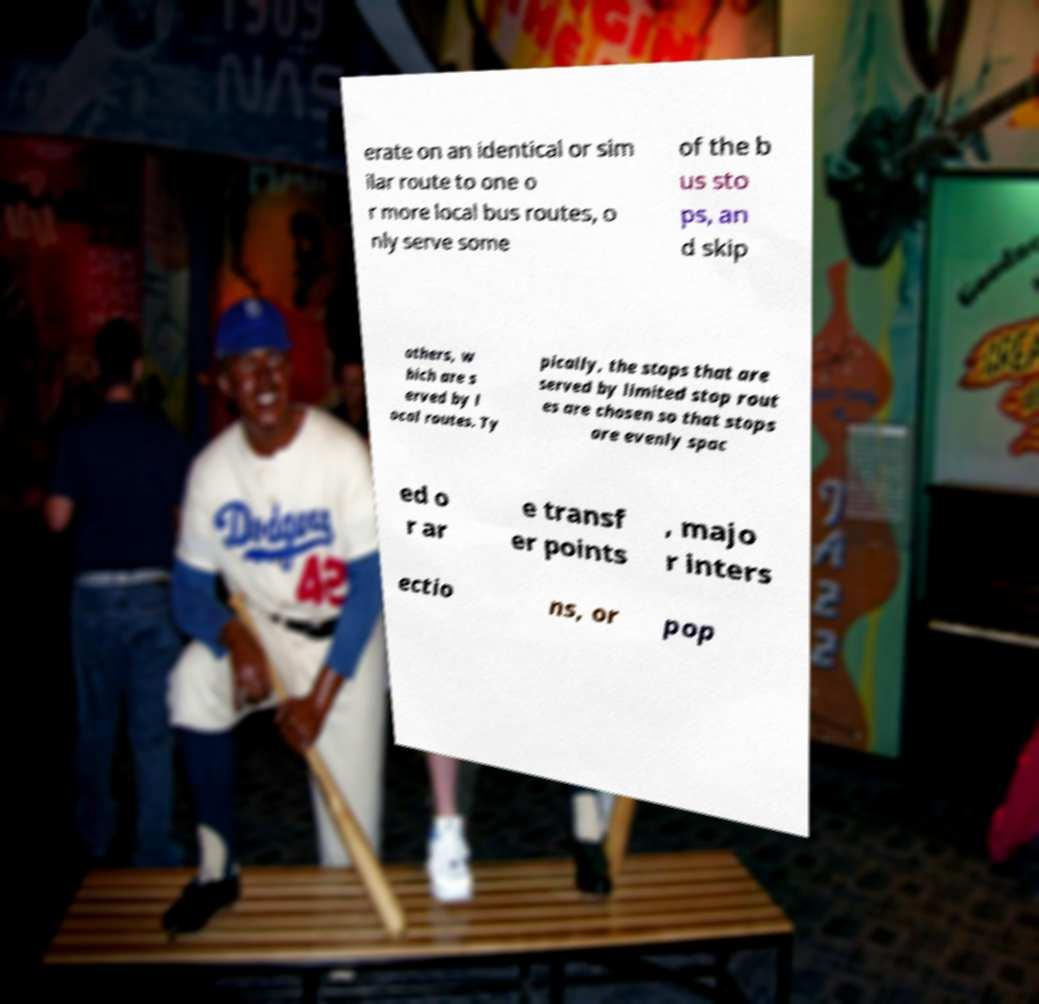Please identify and transcribe the text found in this image. erate on an identical or sim ilar route to one o r more local bus routes, o nly serve some of the b us sto ps, an d skip others, w hich are s erved by l ocal routes. Ty pically, the stops that are served by limited stop rout es are chosen so that stops are evenly spac ed o r ar e transf er points , majo r inters ectio ns, or pop 